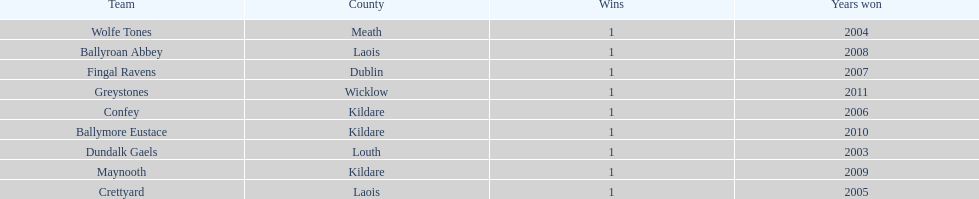What is the years won for each team 2011, 2010, 2009, 2008, 2007, 2006, 2005, 2004, 2003. 